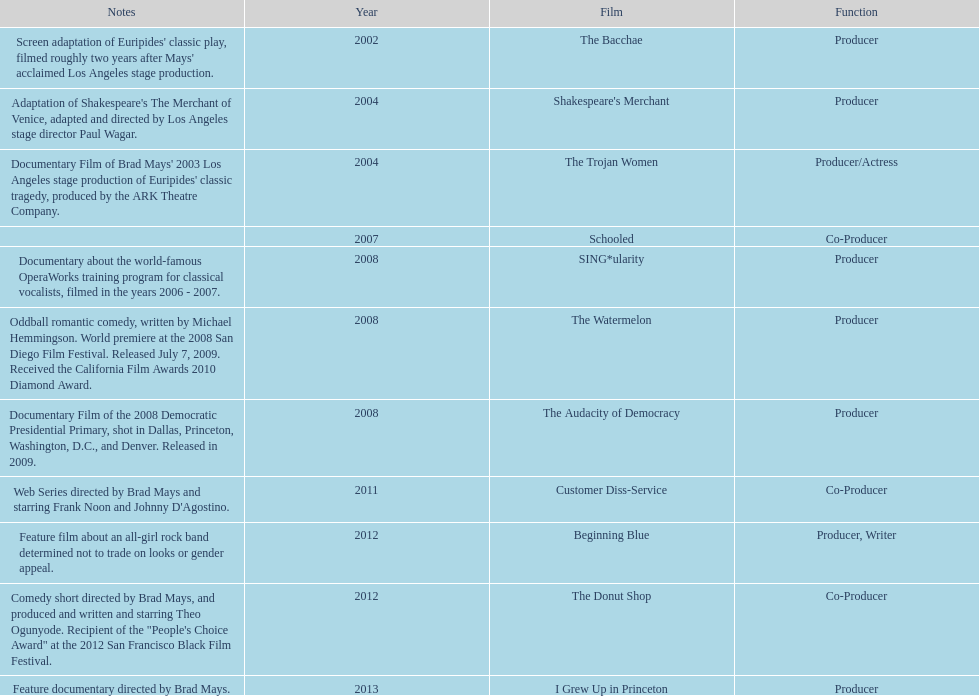How many years before was the film bacchae out before the watermelon? 6. 